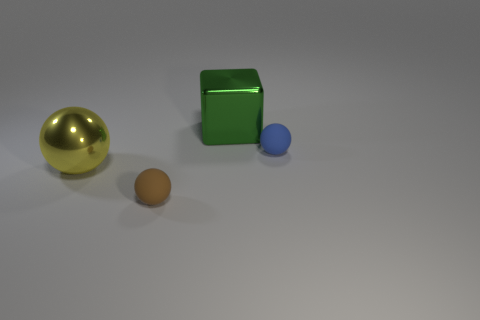How would you describe the overall composition and the lighting of the scene? The composition presents a curated arrangement of geometric shapes with a minimalistic aesthetic. The lighting casts a soft glow that produces gentle shadows on the ground, contributing to an almost serene atmosphere. The variety of sizes and the strategic spacing of the objects create an inviting depth field, prompting viewers to explore the relationship between the elements. 